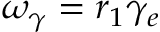Convert formula to latex. <formula><loc_0><loc_0><loc_500><loc_500>\omega _ { \gamma } = r _ { 1 } \gamma _ { e }</formula> 